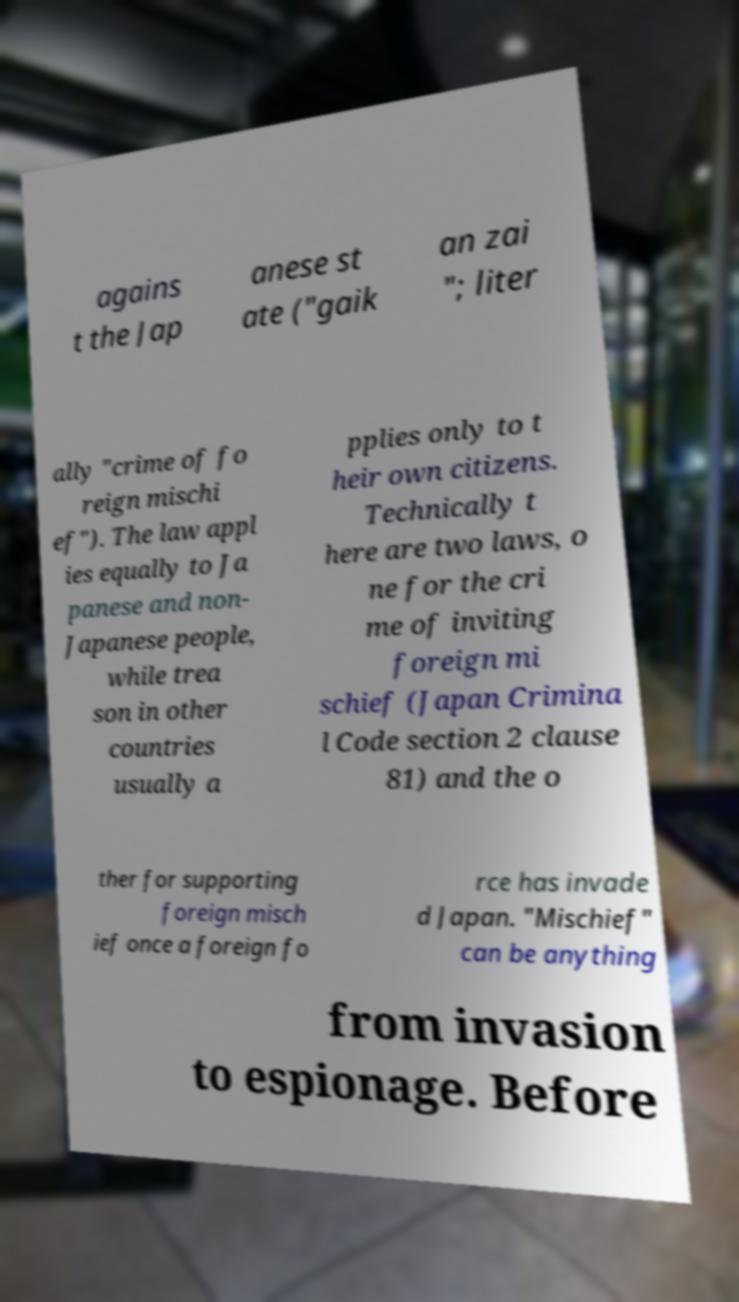For documentation purposes, I need the text within this image transcribed. Could you provide that? agains t the Jap anese st ate ("gaik an zai "; liter ally "crime of fo reign mischi ef"). The law appl ies equally to Ja panese and non- Japanese people, while trea son in other countries usually a pplies only to t heir own citizens. Technically t here are two laws, o ne for the cri me of inviting foreign mi schief (Japan Crimina l Code section 2 clause 81) and the o ther for supporting foreign misch ief once a foreign fo rce has invade d Japan. "Mischief" can be anything from invasion to espionage. Before 